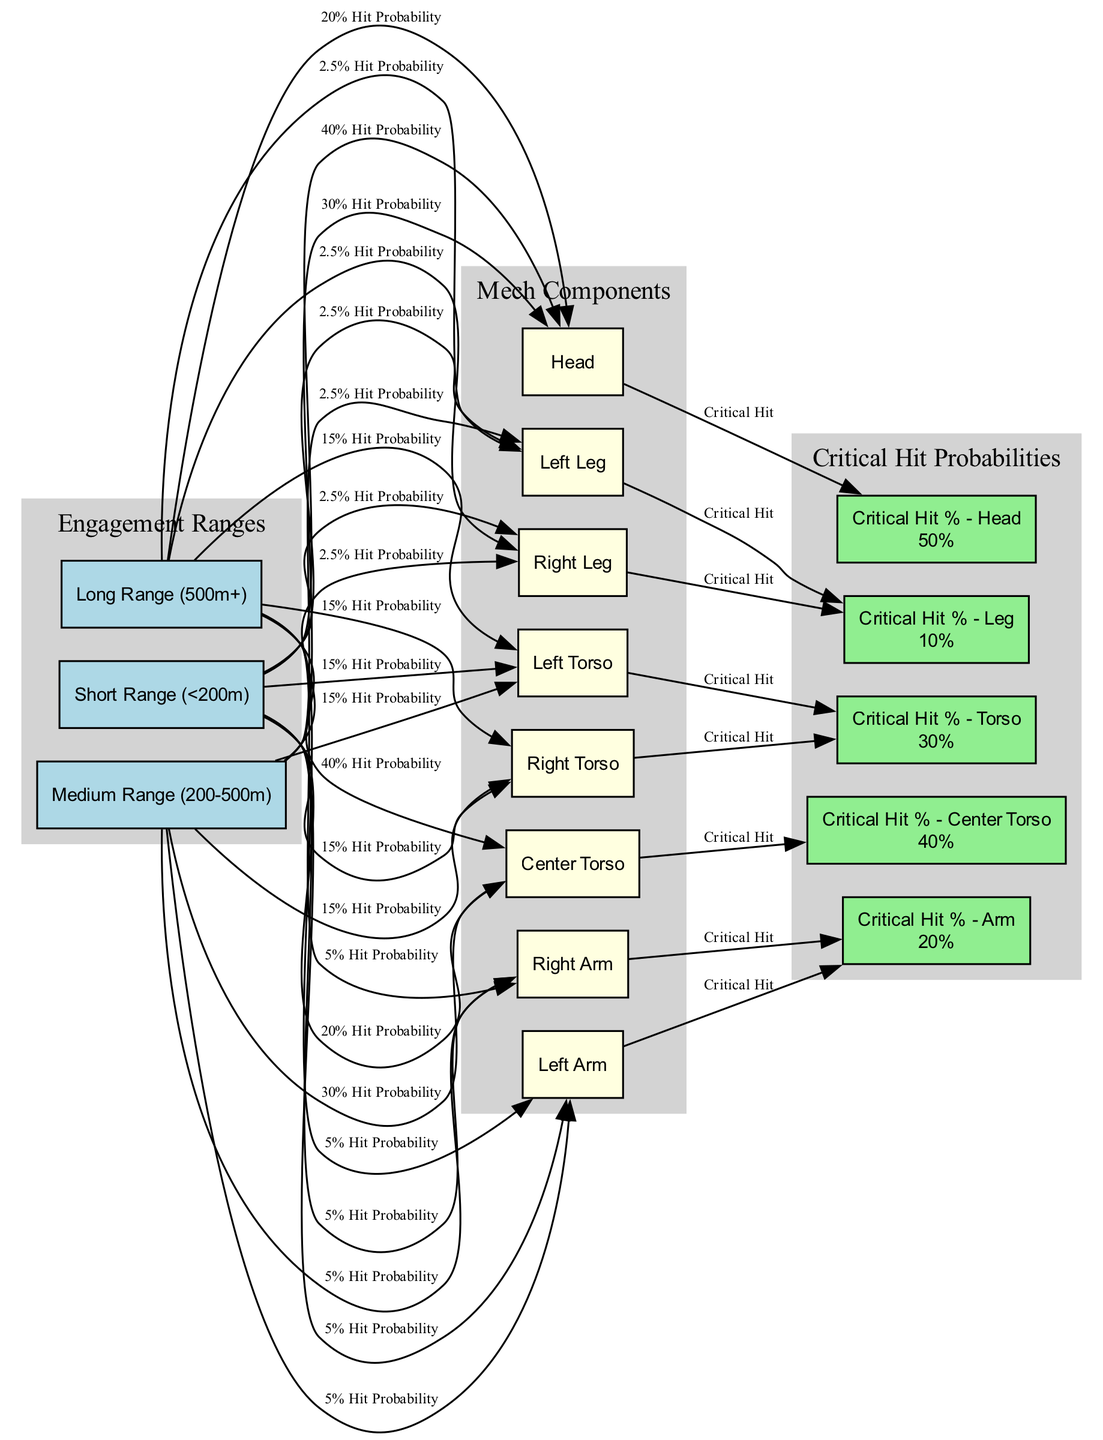What is the critical hit percentage for the head component? According to the diagram, the critical hit percentage for the head component is displayed as a tooltip on the node labeled "Critical Hit % - Head," which indicates a value of 50%.
Answer: 50% What is the hit probability for center torso at medium range? In the diagram, the edge connecting "medium_range" to "center_torso" specifies the hit probability as 30%. This value is found directly on the connecting edge.
Answer: 30% How many components are listed in this diagram? The diagram includes the components identified as head, center torso, left torso, right torso, left arm, right arm, left leg, and right leg, totaling 8 distinct component nodes.
Answer: 8 What is the maximum hit probability possible at long range? The highest hit probability at long range is for the center torso, which is stated on the edge from "long_range" to "center_torso" and is given as 40%.
Answer: 40% Which mech component has the lowest critical hit percentage? The critical hit percentage for the legs (left and right) is indicated as 10%, which is lower than the other component critical hit percentages found in the diagram.
Answer: 10% At short range, what is the hit probability for the head? The diagram shows that the edge from "short_range" to "head" states a hit probability of 40%, which specifically quantifies the chances of hitting that component at that range.
Answer: 40% Which torso component has a critical hit chance of 30%? The left torso and right torso both lead to the node labeled "Critical Hit % - Torso," which denotes a critical hit percentage of 30% for both components as shown by their directed edges.
Answer: 30% What is the hit probability for left leg at long range? The corresponding edge from "long_range" to "left_leg" displays a hit probability of 2.5%, indicating the likelihood of hitting that component from long distance.
Answer: 2.5% 